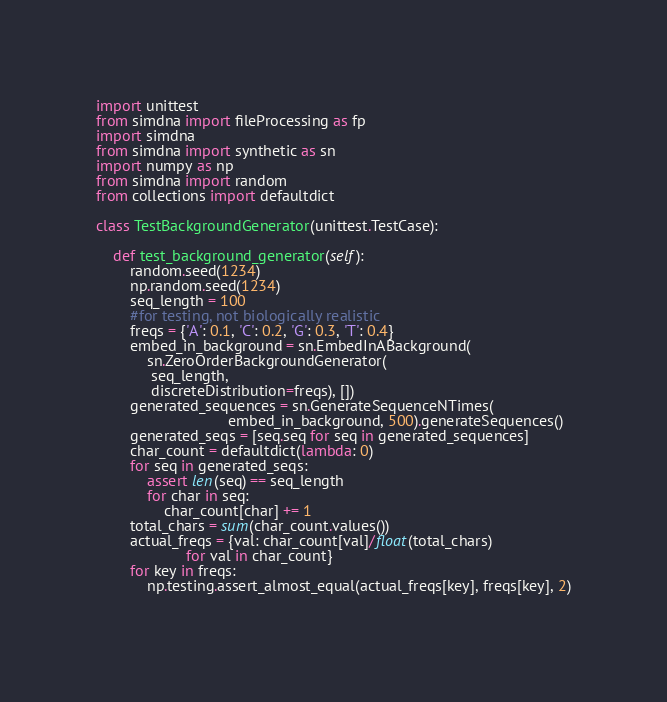<code> <loc_0><loc_0><loc_500><loc_500><_Python_>import unittest
from simdna import fileProcessing as fp
import simdna
from simdna import synthetic as sn
import numpy as np
from simdna import random
from collections import defaultdict

class TestBackgroundGenerator(unittest.TestCase):

    def test_background_generator(self):
        random.seed(1234)
        np.random.seed(1234)
        seq_length = 100
        #for testing, not biologically realistic
        freqs = {'A': 0.1, 'C': 0.2, 'G': 0.3, 'T': 0.4} 
        embed_in_background = sn.EmbedInABackground(
            sn.ZeroOrderBackgroundGenerator(
             seq_length,
             discreteDistribution=freqs), []) 
        generated_sequences = sn.GenerateSequenceNTimes(
                               embed_in_background, 500).generateSequences() 
        generated_seqs = [seq.seq for seq in generated_sequences]
        char_count = defaultdict(lambda: 0)
        for seq in generated_seqs:
            assert len(seq) == seq_length 
            for char in seq:
                char_count[char] += 1 
        total_chars = sum(char_count.values()) 
        actual_freqs = {val: char_count[val]/float(total_chars)
                     for val in char_count}
        for key in freqs:
            np.testing.assert_almost_equal(actual_freqs[key], freqs[key], 2)
        
</code> 